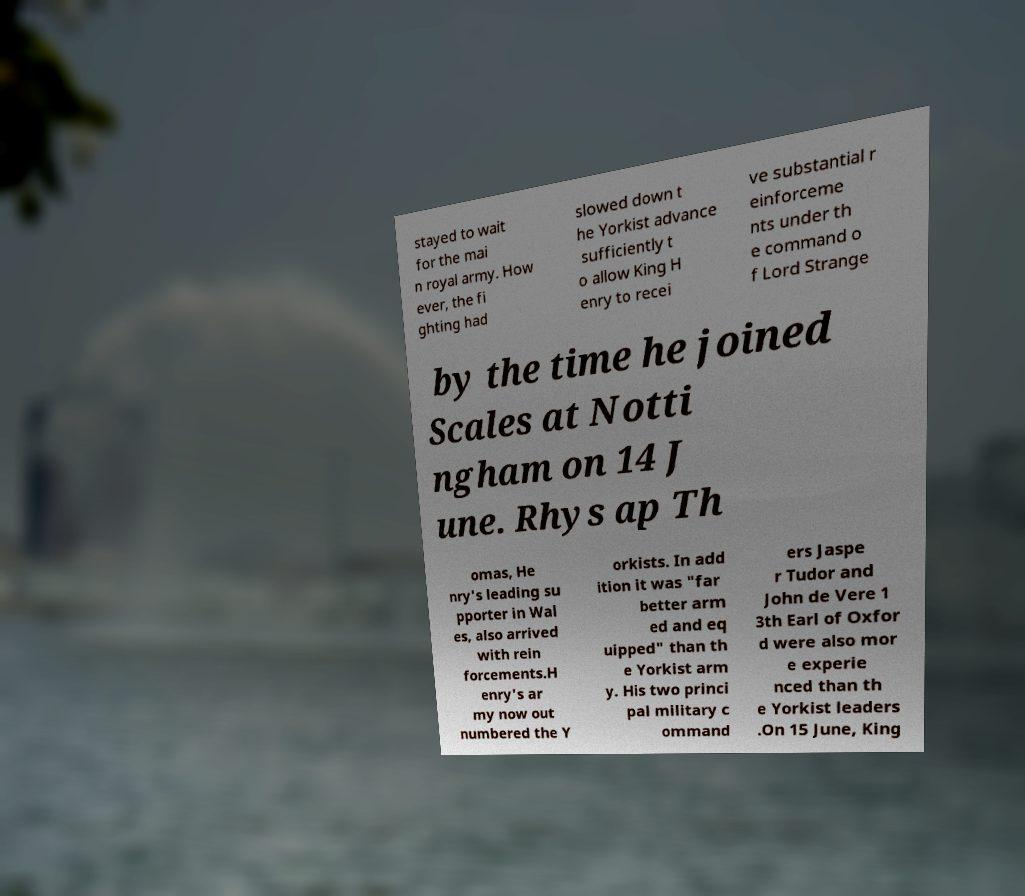Can you accurately transcribe the text from the provided image for me? stayed to wait for the mai n royal army. How ever, the fi ghting had slowed down t he Yorkist advance sufficiently t o allow King H enry to recei ve substantial r einforceme nts under th e command o f Lord Strange by the time he joined Scales at Notti ngham on 14 J une. Rhys ap Th omas, He nry's leading su pporter in Wal es, also arrived with rein forcements.H enry's ar my now out numbered the Y orkists. In add ition it was "far better arm ed and eq uipped" than th e Yorkist arm y. His two princi pal military c ommand ers Jaspe r Tudor and John de Vere 1 3th Earl of Oxfor d were also mor e experie nced than th e Yorkist leaders .On 15 June, King 